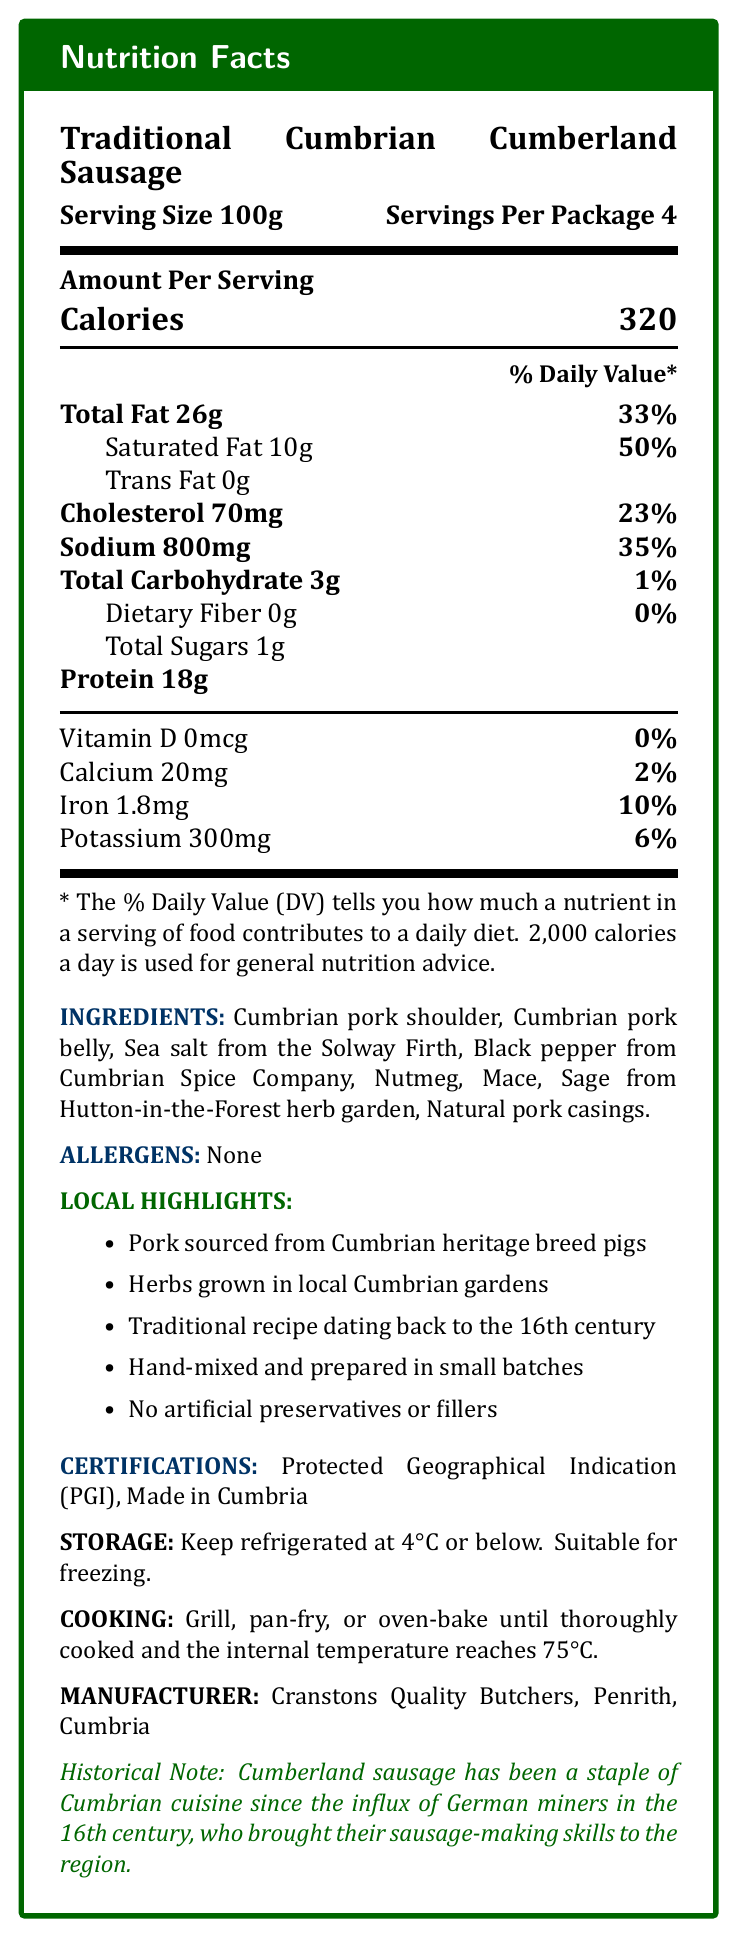what is the serving size of the Traditional Cumbrian Cumberland Sausage? The serving size is stated as "Serving Size 100g" in the top section of the label.
Answer: 100g how many servings are in one package of Traditional Cumbrian Cumberland Sausage? It is mentioned as "Servings Per Package 4" in the top section of the label.
Answer: 4 how many calories are in one serving of the sausage? It is displayed as "Calories 320" in the "Amount Per Serving" section.
Answer: 320 where is the sea salt used in the sausages sourced from? The ingredients list specifies "Sea salt from the Solway Firth."
Answer: Solway Firth what percentage of the daily value for saturated fat does one serving contain? The "Daily Value" for saturated fat is displayed as "50%" next to "Saturated Fat 10g".
Answer: 50% which company supplies the black pepper used in the sausages? A. Cumberland Spice Company B. Cumbrian Spice Company C. Cumbria Spice Co. The correct company name is given as "Black pepper from Cumbrian Spice Company" in the ingredients list.
Answer: B which of the following is a local highlight of the sausage production? I. Pork sourced from Cumbrian heritage breed pigs II. Farm-to-table supply chain III. Hand-mixed and prepared in small batches The local highlights listed include "Pork sourced from Cumbrian heritage breed pigs" and "Hand-mixed and prepared in small batches," but not "Farm-to-table supply chain."
Answer: I, III should people with nut allergies avoid this sausage? Yes/No The allergens section indicates "None," meaning there are no listed allergens such as nuts.
Answer: No describe the main idea of the nutrition facts label for the Traditional Cumbrian Cumberland Sausage. This condensed summary encompasses the nutritional data, ingredients, local sourcing, historical note, certifications, as well as storage and cooking instructions provided on the label.
Answer: The label provides detailed nutritional information, ingredients, allergens, and local highlights specific to Traditional Cumbrian Cumberland Sausage. The sausage is made from local Cumbrian pork, seasoned with spices and herbs from the region, and is free from artificial preservatives. It also has several certifications, including Protected Geographical Indication (PGI) and mentions its historical significance. Storage and cooking instructions are provided, as well as the manufacturer information. how much protein is in the Traditional Cumbrian Cumberland Sausage per serving? The amount of protein per serving is indicated as "Protein 18g."
Answer: 18g what are the storage instructions for the sausage? The storage instructions specify to "Keep refrigerated at 4°C or below" and that it is "Suitable for freezing."
Answer: Keep refrigerated at 4°C or below. Suitable for freezing. what is the iron content in a single serving, and how does it relate to the daily value? The iron content per serving is listed as "Iron 1.8mg" and "10%" daily value.
Answer: 1.8mg, 10% which year did German miners introduce sausage-making skills to Cumbria? The document states that sausage-making skills were introduced by German miners in the 16th century but does not specify an exact year.
Answer: Cannot be determined 